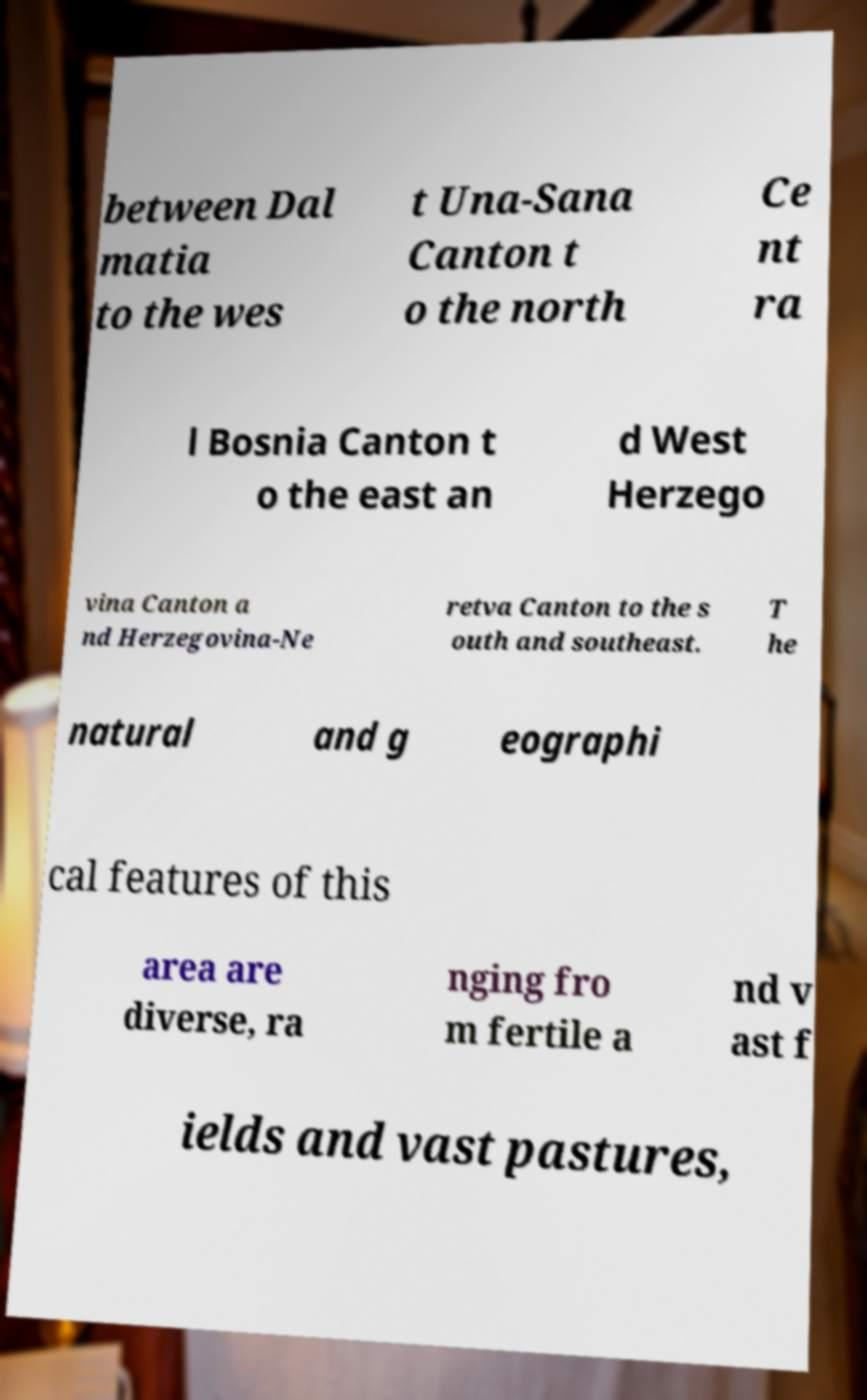Please identify and transcribe the text found in this image. between Dal matia to the wes t Una-Sana Canton t o the north Ce nt ra l Bosnia Canton t o the east an d West Herzego vina Canton a nd Herzegovina-Ne retva Canton to the s outh and southeast. T he natural and g eographi cal features of this area are diverse, ra nging fro m fertile a nd v ast f ields and vast pastures, 